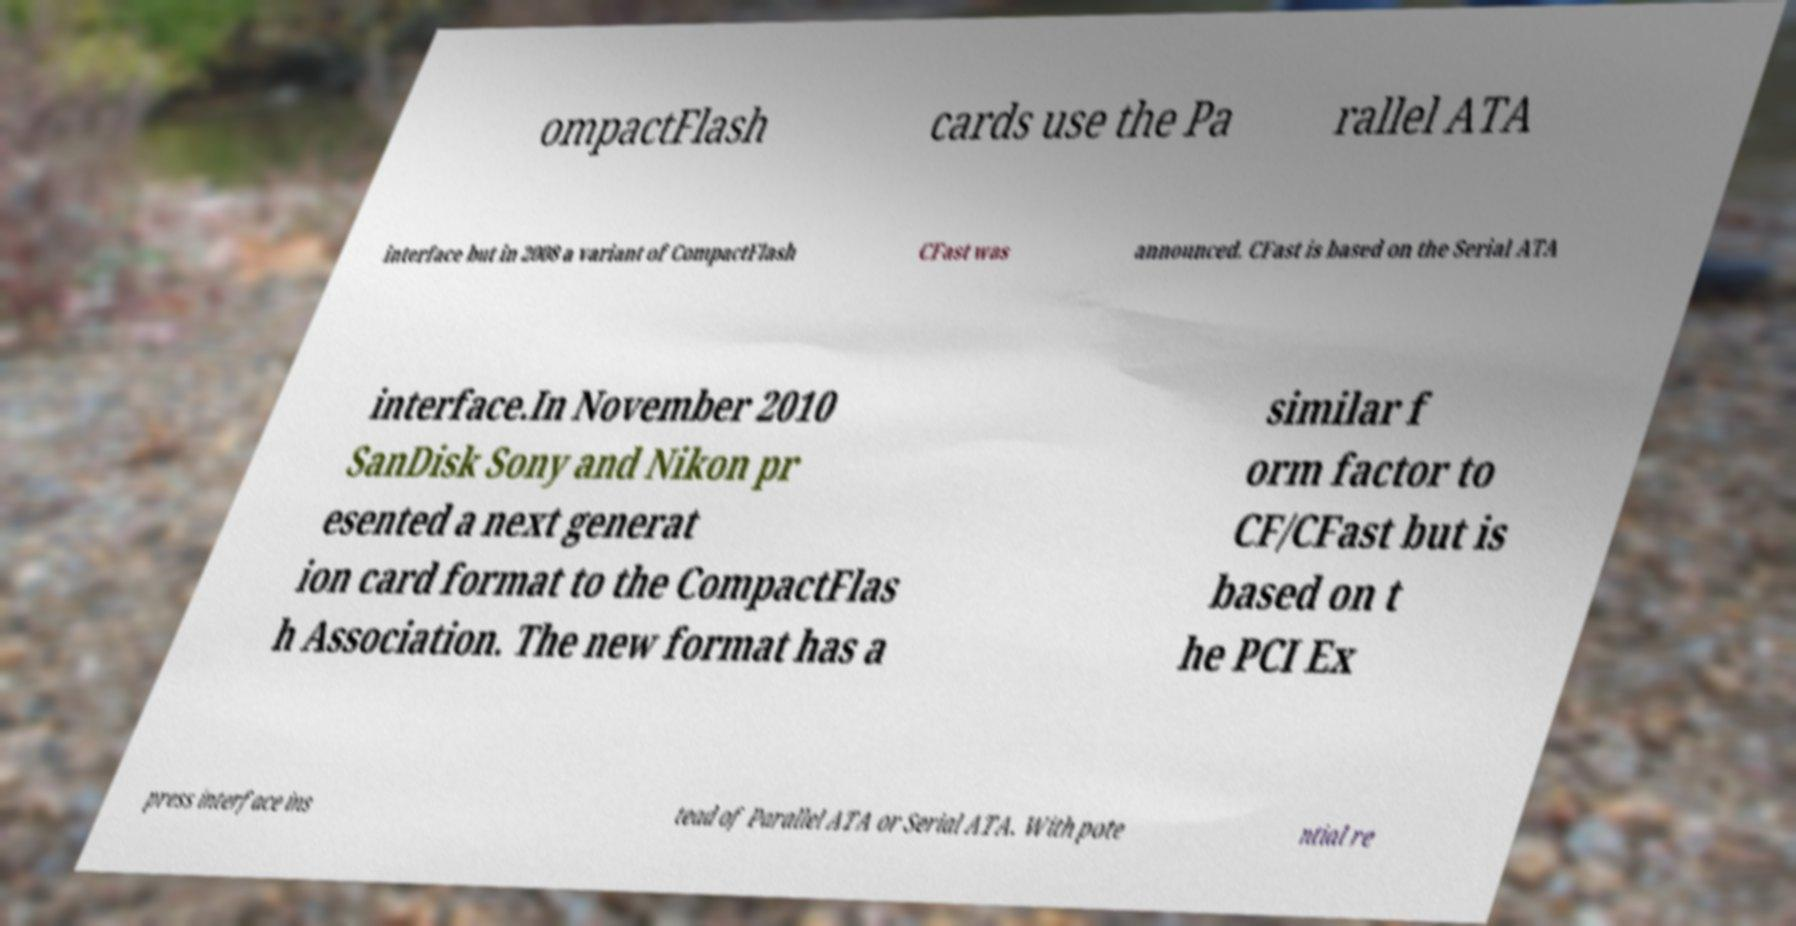Can you read and provide the text displayed in the image?This photo seems to have some interesting text. Can you extract and type it out for me? ompactFlash cards use the Pa rallel ATA interface but in 2008 a variant of CompactFlash CFast was announced. CFast is based on the Serial ATA interface.In November 2010 SanDisk Sony and Nikon pr esented a next generat ion card format to the CompactFlas h Association. The new format has a similar f orm factor to CF/CFast but is based on t he PCI Ex press interface ins tead of Parallel ATA or Serial ATA. With pote ntial re 